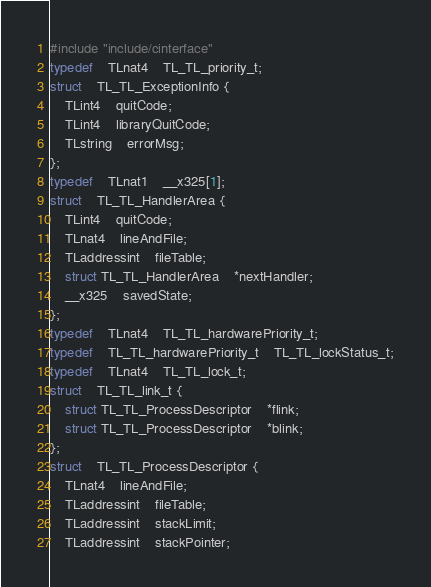Convert code to text. <code><loc_0><loc_0><loc_500><loc_500><_C_>#include "include/cinterface"
typedef	TLnat4	TL_TL_priority_t;
struct	TL_TL_ExceptionInfo {
    TLint4	quitCode;
    TLint4	libraryQuitCode;
    TLstring	errorMsg;
};
typedef	TLnat1	__x325[1];
struct	TL_TL_HandlerArea {
    TLint4	quitCode;
    TLnat4	lineAndFile;
    TLaddressint	fileTable;
    struct TL_TL_HandlerArea	*nextHandler;
    __x325	savedState;
};
typedef	TLnat4	TL_TL_hardwarePriority_t;
typedef	TL_TL_hardwarePriority_t	TL_TL_lockStatus_t;
typedef	TLnat4	TL_TL_lock_t;
struct	TL_TL_link_t {
    struct TL_TL_ProcessDescriptor	*flink;
    struct TL_TL_ProcessDescriptor	*blink;
};
struct	TL_TL_ProcessDescriptor {
    TLnat4	lineAndFile;
    TLaddressint	fileTable;
    TLaddressint	stackLimit;
    TLaddressint	stackPointer;</code> 